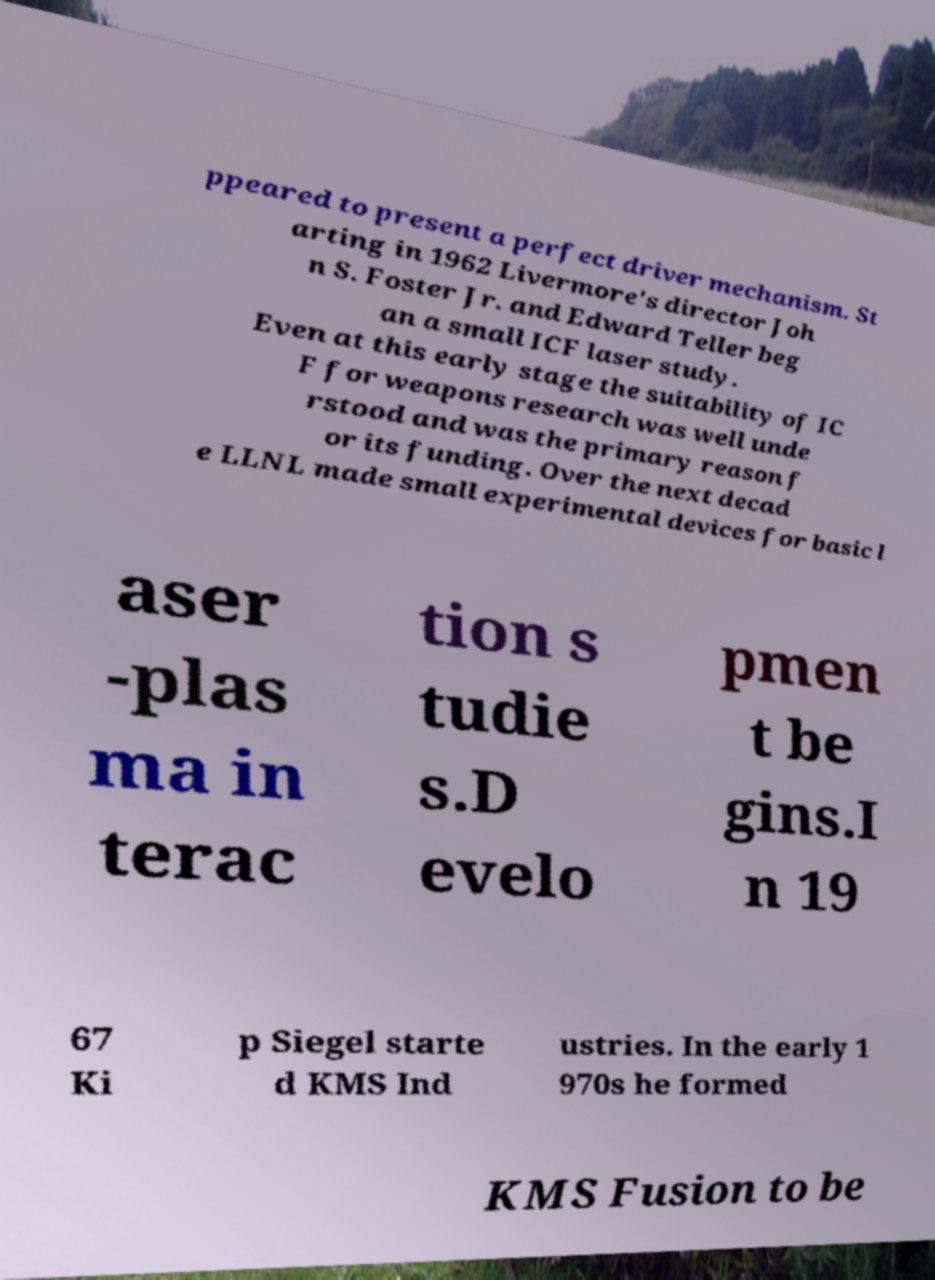Can you read and provide the text displayed in the image?This photo seems to have some interesting text. Can you extract and type it out for me? ppeared to present a perfect driver mechanism. St arting in 1962 Livermore's director Joh n S. Foster Jr. and Edward Teller beg an a small ICF laser study. Even at this early stage the suitability of IC F for weapons research was well unde rstood and was the primary reason f or its funding. Over the next decad e LLNL made small experimental devices for basic l aser -plas ma in terac tion s tudie s.D evelo pmen t be gins.I n 19 67 Ki p Siegel starte d KMS Ind ustries. In the early 1 970s he formed KMS Fusion to be 